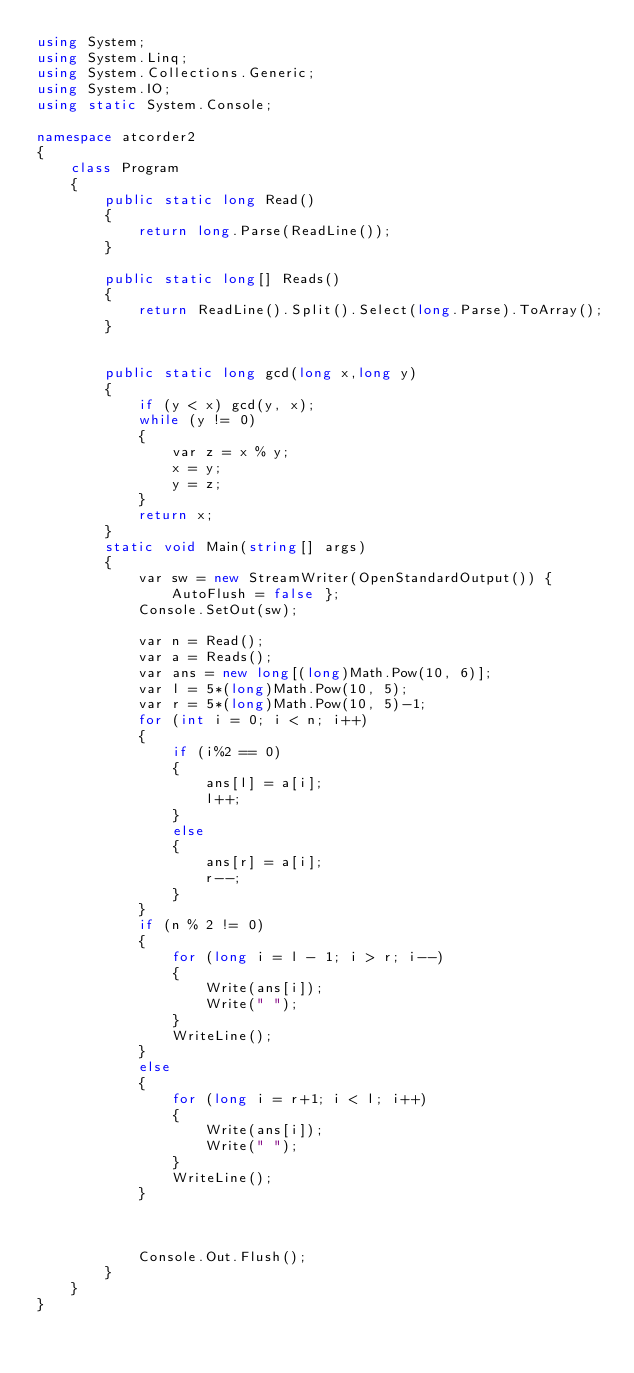Convert code to text. <code><loc_0><loc_0><loc_500><loc_500><_C#_>using System;
using System.Linq;
using System.Collections.Generic;
using System.IO;
using static System.Console;

namespace atcorder2
{
    class Program
    {
        public static long Read()
        {
            return long.Parse(ReadLine());
        }

        public static long[] Reads()
        {
            return ReadLine().Split().Select(long.Parse).ToArray();
        }


        public static long gcd(long x,long y)
        {
            if (y < x) gcd(y, x);
            while (y != 0)
            {
                var z = x % y;
                x = y;
                y = z;
            }
            return x;
        }
        static void Main(string[] args)
        {
            var sw = new StreamWriter(OpenStandardOutput()) { AutoFlush = false };
            Console.SetOut(sw);

            var n = Read();         
            var a = Reads();
            var ans = new long[(long)Math.Pow(10, 6)];
            var l = 5*(long)Math.Pow(10, 5);
            var r = 5*(long)Math.Pow(10, 5)-1;
            for (int i = 0; i < n; i++)
            {
                if (i%2 == 0)
                {
                    ans[l] = a[i];
                    l++;
                }
                else
                {
                    ans[r] = a[i];
                    r--;
                }
            }
            if (n % 2 != 0)
            {
                for (long i = l - 1; i > r; i--)
                {
                    Write(ans[i]);
                    Write(" ");
                }
                WriteLine();
            }
            else
            {
                for (long i = r+1; i < l; i++)
                {
                    Write(ans[i]);
                    Write(" ");
                }
                WriteLine();
            }

            

            Console.Out.Flush();
        }
    }
}
</code> 